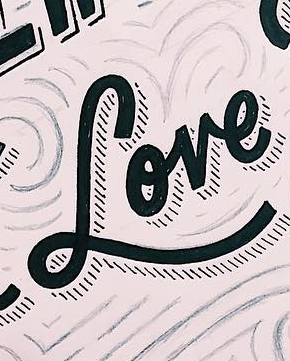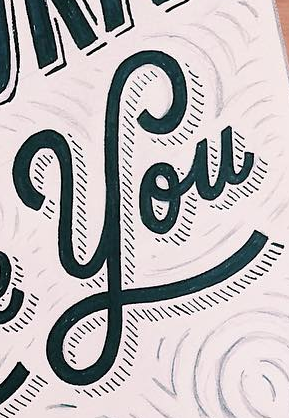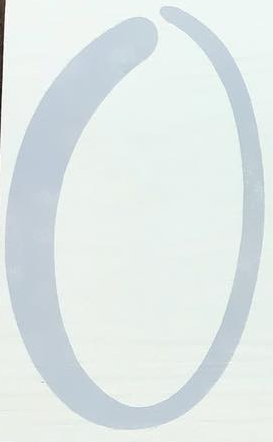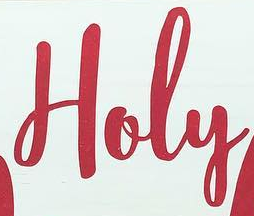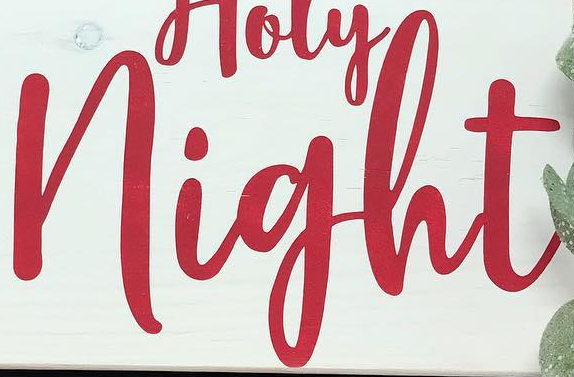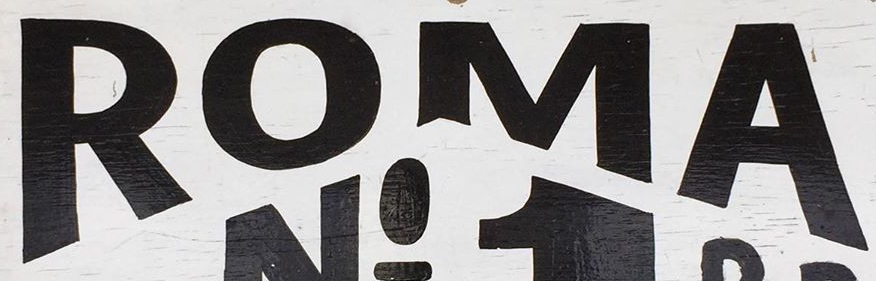Transcribe the words shown in these images in order, separated by a semicolon. Love; You; O; Holy; night; ROMA 